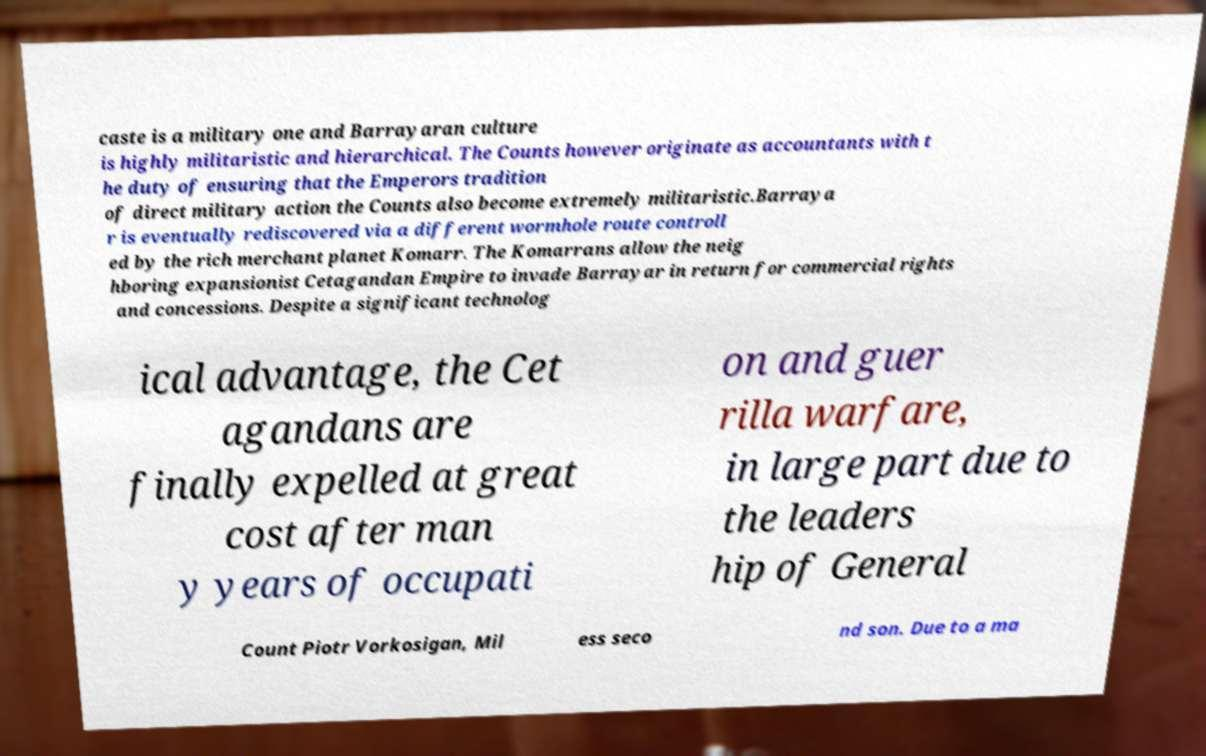Can you accurately transcribe the text from the provided image for me? caste is a military one and Barrayaran culture is highly militaristic and hierarchical. The Counts however originate as accountants with t he duty of ensuring that the Emperors tradition of direct military action the Counts also become extremely militaristic.Barraya r is eventually rediscovered via a different wormhole route controll ed by the rich merchant planet Komarr. The Komarrans allow the neig hboring expansionist Cetagandan Empire to invade Barrayar in return for commercial rights and concessions. Despite a significant technolog ical advantage, the Cet agandans are finally expelled at great cost after man y years of occupati on and guer rilla warfare, in large part due to the leaders hip of General Count Piotr Vorkosigan, Mil ess seco nd son. Due to a ma 